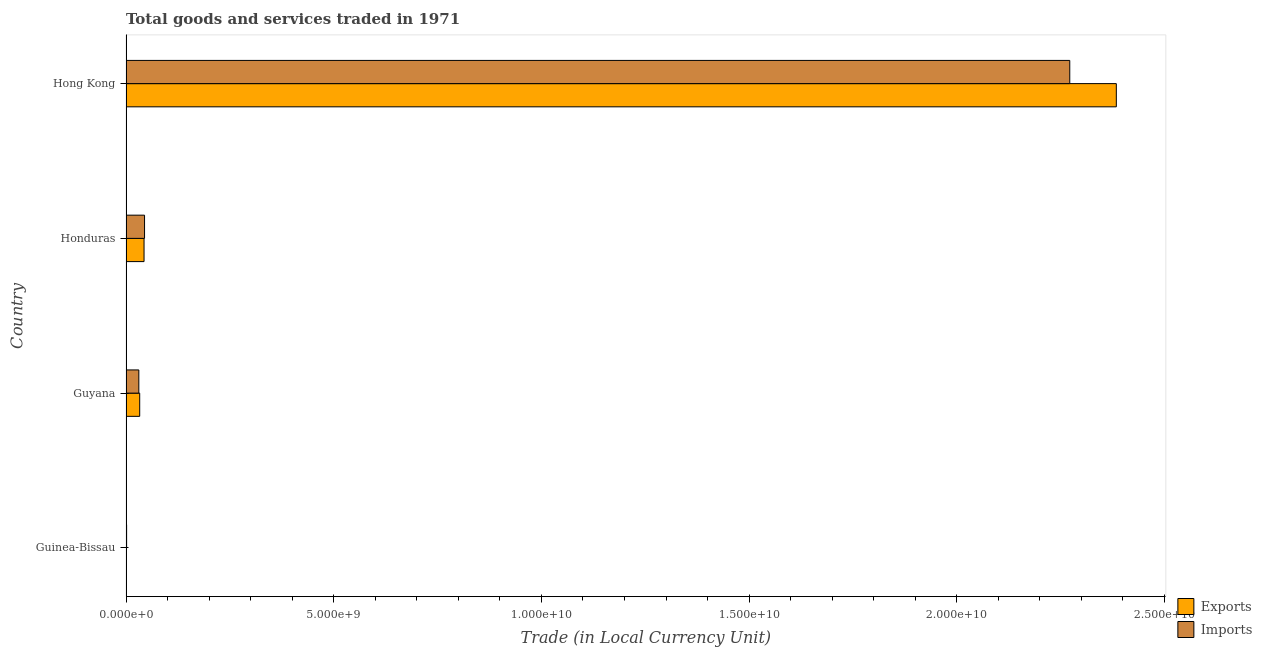How many different coloured bars are there?
Your answer should be very brief. 2. Are the number of bars per tick equal to the number of legend labels?
Offer a terse response. Yes. How many bars are there on the 3rd tick from the bottom?
Offer a very short reply. 2. What is the label of the 4th group of bars from the top?
Your response must be concise. Guinea-Bissau. In how many cases, is the number of bars for a given country not equal to the number of legend labels?
Provide a succinct answer. 0. What is the imports of goods and services in Honduras?
Your answer should be very brief. 4.46e+08. Across all countries, what is the maximum export of goods and services?
Provide a succinct answer. 2.38e+1. Across all countries, what is the minimum imports of goods and services?
Make the answer very short. 1.45e+07. In which country was the imports of goods and services maximum?
Provide a succinct answer. Hong Kong. In which country was the imports of goods and services minimum?
Provide a short and direct response. Guinea-Bissau. What is the total export of goods and services in the graph?
Provide a short and direct response. 2.46e+1. What is the difference between the export of goods and services in Guyana and that in Hong Kong?
Offer a terse response. -2.35e+1. What is the difference between the export of goods and services in Honduras and the imports of goods and services in Hong Kong?
Offer a very short reply. -2.23e+1. What is the average imports of goods and services per country?
Offer a very short reply. 5.87e+09. What is the difference between the imports of goods and services and export of goods and services in Guinea-Bissau?
Provide a succinct answer. 1.28e+07. In how many countries, is the export of goods and services greater than 20000000000 LCU?
Give a very brief answer. 1. What is the ratio of the imports of goods and services in Guyana to that in Hong Kong?
Make the answer very short. 0.01. Is the imports of goods and services in Guinea-Bissau less than that in Guyana?
Provide a short and direct response. Yes. What is the difference between the highest and the second highest imports of goods and services?
Ensure brevity in your answer.  2.23e+1. What is the difference between the highest and the lowest imports of goods and services?
Your response must be concise. 2.27e+1. In how many countries, is the export of goods and services greater than the average export of goods and services taken over all countries?
Keep it short and to the point. 1. Is the sum of the export of goods and services in Honduras and Hong Kong greater than the maximum imports of goods and services across all countries?
Your response must be concise. Yes. What does the 2nd bar from the top in Honduras represents?
Ensure brevity in your answer.  Exports. What does the 2nd bar from the bottom in Honduras represents?
Make the answer very short. Imports. How many bars are there?
Provide a succinct answer. 8. Are all the bars in the graph horizontal?
Your answer should be very brief. Yes. How many countries are there in the graph?
Offer a terse response. 4. What is the difference between two consecutive major ticks on the X-axis?
Keep it short and to the point. 5.00e+09. Are the values on the major ticks of X-axis written in scientific E-notation?
Your response must be concise. Yes. Does the graph contain any zero values?
Provide a short and direct response. No. Does the graph contain grids?
Keep it short and to the point. No. Where does the legend appear in the graph?
Your answer should be very brief. Bottom right. How many legend labels are there?
Offer a terse response. 2. How are the legend labels stacked?
Your response must be concise. Vertical. What is the title of the graph?
Your answer should be very brief. Total goods and services traded in 1971. Does "Central government" appear as one of the legend labels in the graph?
Offer a very short reply. No. What is the label or title of the X-axis?
Ensure brevity in your answer.  Trade (in Local Currency Unit). What is the Trade (in Local Currency Unit) in Exports in Guinea-Bissau?
Offer a very short reply. 1.76e+06. What is the Trade (in Local Currency Unit) in Imports in Guinea-Bissau?
Provide a short and direct response. 1.45e+07. What is the Trade (in Local Currency Unit) of Exports in Guyana?
Ensure brevity in your answer.  3.30e+08. What is the Trade (in Local Currency Unit) in Imports in Guyana?
Ensure brevity in your answer.  3.08e+08. What is the Trade (in Local Currency Unit) of Exports in Honduras?
Your response must be concise. 4.34e+08. What is the Trade (in Local Currency Unit) in Imports in Honduras?
Keep it short and to the point. 4.46e+08. What is the Trade (in Local Currency Unit) of Exports in Hong Kong?
Your answer should be very brief. 2.38e+1. What is the Trade (in Local Currency Unit) in Imports in Hong Kong?
Provide a succinct answer. 2.27e+1. Across all countries, what is the maximum Trade (in Local Currency Unit) of Exports?
Ensure brevity in your answer.  2.38e+1. Across all countries, what is the maximum Trade (in Local Currency Unit) in Imports?
Make the answer very short. 2.27e+1. Across all countries, what is the minimum Trade (in Local Currency Unit) in Exports?
Give a very brief answer. 1.76e+06. Across all countries, what is the minimum Trade (in Local Currency Unit) in Imports?
Keep it short and to the point. 1.45e+07. What is the total Trade (in Local Currency Unit) in Exports in the graph?
Keep it short and to the point. 2.46e+1. What is the total Trade (in Local Currency Unit) of Imports in the graph?
Provide a succinct answer. 2.35e+1. What is the difference between the Trade (in Local Currency Unit) in Exports in Guinea-Bissau and that in Guyana?
Your answer should be very brief. -3.28e+08. What is the difference between the Trade (in Local Currency Unit) of Imports in Guinea-Bissau and that in Guyana?
Offer a very short reply. -2.94e+08. What is the difference between the Trade (in Local Currency Unit) of Exports in Guinea-Bissau and that in Honduras?
Your answer should be very brief. -4.32e+08. What is the difference between the Trade (in Local Currency Unit) in Imports in Guinea-Bissau and that in Honduras?
Your answer should be very brief. -4.31e+08. What is the difference between the Trade (in Local Currency Unit) in Exports in Guinea-Bissau and that in Hong Kong?
Offer a terse response. -2.38e+1. What is the difference between the Trade (in Local Currency Unit) in Imports in Guinea-Bissau and that in Hong Kong?
Your response must be concise. -2.27e+1. What is the difference between the Trade (in Local Currency Unit) in Exports in Guyana and that in Honduras?
Provide a succinct answer. -1.04e+08. What is the difference between the Trade (in Local Currency Unit) in Imports in Guyana and that in Honduras?
Make the answer very short. -1.38e+08. What is the difference between the Trade (in Local Currency Unit) in Exports in Guyana and that in Hong Kong?
Your answer should be very brief. -2.35e+1. What is the difference between the Trade (in Local Currency Unit) of Imports in Guyana and that in Hong Kong?
Make the answer very short. -2.24e+1. What is the difference between the Trade (in Local Currency Unit) of Exports in Honduras and that in Hong Kong?
Ensure brevity in your answer.  -2.34e+1. What is the difference between the Trade (in Local Currency Unit) in Imports in Honduras and that in Hong Kong?
Keep it short and to the point. -2.23e+1. What is the difference between the Trade (in Local Currency Unit) of Exports in Guinea-Bissau and the Trade (in Local Currency Unit) of Imports in Guyana?
Your answer should be very brief. -3.07e+08. What is the difference between the Trade (in Local Currency Unit) of Exports in Guinea-Bissau and the Trade (in Local Currency Unit) of Imports in Honduras?
Provide a short and direct response. -4.44e+08. What is the difference between the Trade (in Local Currency Unit) in Exports in Guinea-Bissau and the Trade (in Local Currency Unit) in Imports in Hong Kong?
Offer a terse response. -2.27e+1. What is the difference between the Trade (in Local Currency Unit) of Exports in Guyana and the Trade (in Local Currency Unit) of Imports in Honduras?
Your answer should be very brief. -1.16e+08. What is the difference between the Trade (in Local Currency Unit) in Exports in Guyana and the Trade (in Local Currency Unit) in Imports in Hong Kong?
Ensure brevity in your answer.  -2.24e+1. What is the difference between the Trade (in Local Currency Unit) in Exports in Honduras and the Trade (in Local Currency Unit) in Imports in Hong Kong?
Your answer should be compact. -2.23e+1. What is the average Trade (in Local Currency Unit) in Exports per country?
Provide a short and direct response. 6.15e+09. What is the average Trade (in Local Currency Unit) of Imports per country?
Keep it short and to the point. 5.87e+09. What is the difference between the Trade (in Local Currency Unit) of Exports and Trade (in Local Currency Unit) of Imports in Guinea-Bissau?
Your answer should be very brief. -1.28e+07. What is the difference between the Trade (in Local Currency Unit) of Exports and Trade (in Local Currency Unit) of Imports in Guyana?
Ensure brevity in your answer.  2.10e+07. What is the difference between the Trade (in Local Currency Unit) in Exports and Trade (in Local Currency Unit) in Imports in Honduras?
Your answer should be very brief. -1.20e+07. What is the difference between the Trade (in Local Currency Unit) in Exports and Trade (in Local Currency Unit) in Imports in Hong Kong?
Give a very brief answer. 1.12e+09. What is the ratio of the Trade (in Local Currency Unit) in Exports in Guinea-Bissau to that in Guyana?
Offer a very short reply. 0.01. What is the ratio of the Trade (in Local Currency Unit) in Imports in Guinea-Bissau to that in Guyana?
Your answer should be very brief. 0.05. What is the ratio of the Trade (in Local Currency Unit) of Exports in Guinea-Bissau to that in Honduras?
Your answer should be compact. 0. What is the ratio of the Trade (in Local Currency Unit) of Imports in Guinea-Bissau to that in Honduras?
Your response must be concise. 0.03. What is the ratio of the Trade (in Local Currency Unit) in Imports in Guinea-Bissau to that in Hong Kong?
Provide a short and direct response. 0. What is the ratio of the Trade (in Local Currency Unit) in Exports in Guyana to that in Honduras?
Your answer should be very brief. 0.76. What is the ratio of the Trade (in Local Currency Unit) in Imports in Guyana to that in Honduras?
Offer a terse response. 0.69. What is the ratio of the Trade (in Local Currency Unit) of Exports in Guyana to that in Hong Kong?
Provide a short and direct response. 0.01. What is the ratio of the Trade (in Local Currency Unit) in Imports in Guyana to that in Hong Kong?
Provide a succinct answer. 0.01. What is the ratio of the Trade (in Local Currency Unit) in Exports in Honduras to that in Hong Kong?
Your response must be concise. 0.02. What is the ratio of the Trade (in Local Currency Unit) in Imports in Honduras to that in Hong Kong?
Your answer should be compact. 0.02. What is the difference between the highest and the second highest Trade (in Local Currency Unit) in Exports?
Keep it short and to the point. 2.34e+1. What is the difference between the highest and the second highest Trade (in Local Currency Unit) of Imports?
Your response must be concise. 2.23e+1. What is the difference between the highest and the lowest Trade (in Local Currency Unit) in Exports?
Give a very brief answer. 2.38e+1. What is the difference between the highest and the lowest Trade (in Local Currency Unit) of Imports?
Your answer should be compact. 2.27e+1. 